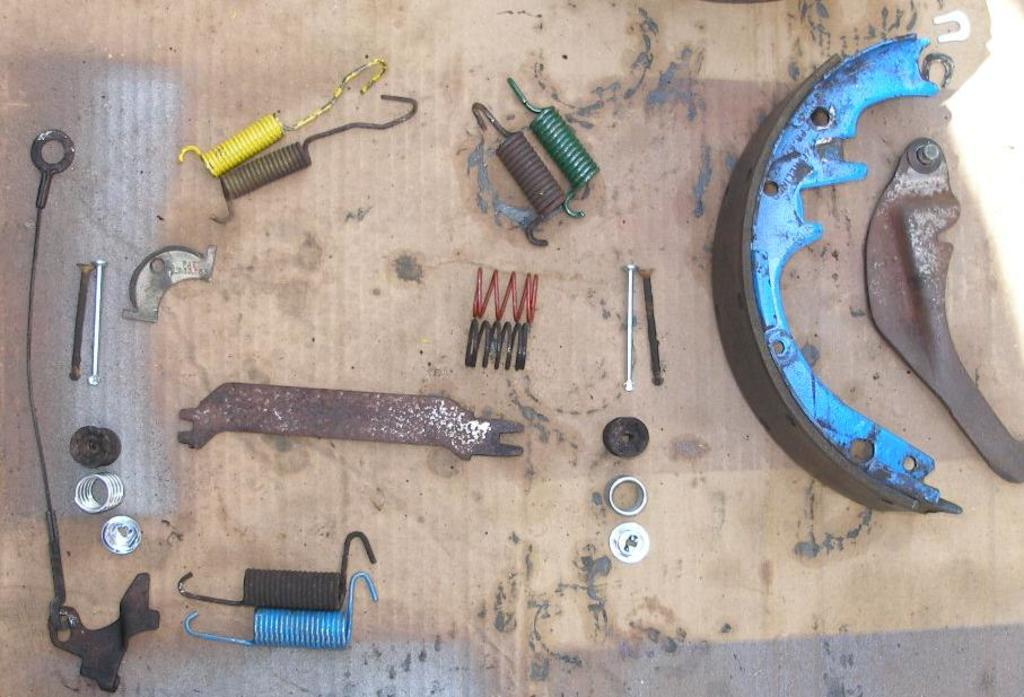What type of objects can be seen in the image? There are metal tools in the image. Are there any other objects besides the metal tools? Yes, there are other objects in the image. Where are the objects placed? The objects are placed on a surface that resembles a table. What type of mask is being worn by the bird in the image? There is no bird or mask present in the image; it only features metal tools and other objects on a table-like surface. 